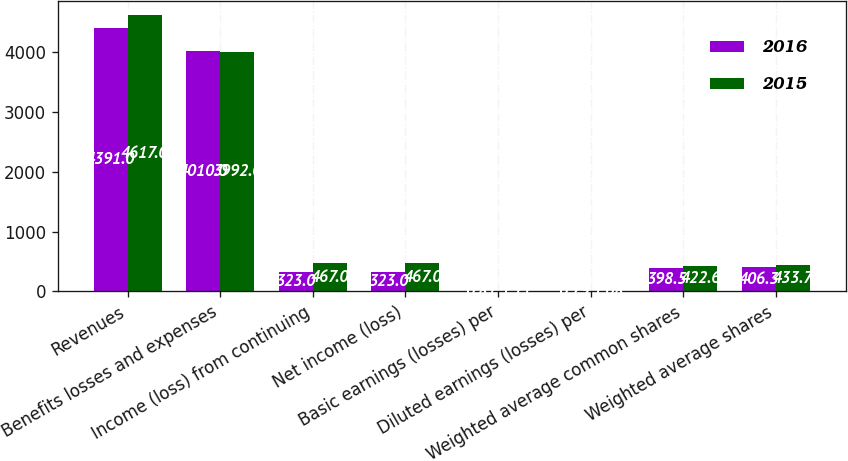Convert chart. <chart><loc_0><loc_0><loc_500><loc_500><stacked_bar_chart><ecel><fcel>Revenues<fcel>Benefits losses and expenses<fcel>Income (loss) from continuing<fcel>Net income (loss)<fcel>Basic earnings (losses) per<fcel>Diluted earnings (losses) per<fcel>Weighted average common shares<fcel>Weighted average shares<nl><fcel>2016<fcel>4391<fcel>4010<fcel>323<fcel>323<fcel>0.81<fcel>0.79<fcel>398.5<fcel>406.3<nl><fcel>2015<fcel>4617<fcel>3992<fcel>467<fcel>467<fcel>1.11<fcel>1.08<fcel>422.6<fcel>433.7<nl></chart> 